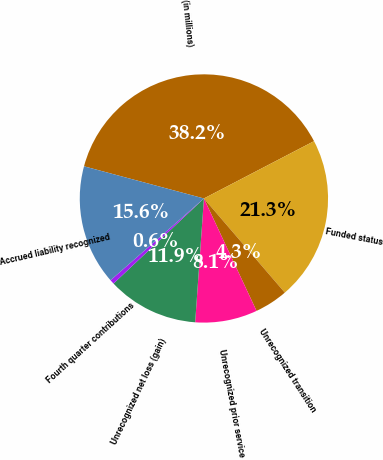Convert chart. <chart><loc_0><loc_0><loc_500><loc_500><pie_chart><fcel>(in millions)<fcel>Funded status<fcel>Unrecognized transition<fcel>Unrecognized prior service<fcel>Unrecognized net loss (gain)<fcel>Fourth quarter contributions<fcel>Accrued liability recognized<nl><fcel>38.19%<fcel>21.34%<fcel>4.33%<fcel>8.09%<fcel>11.86%<fcel>0.57%<fcel>15.62%<nl></chart> 